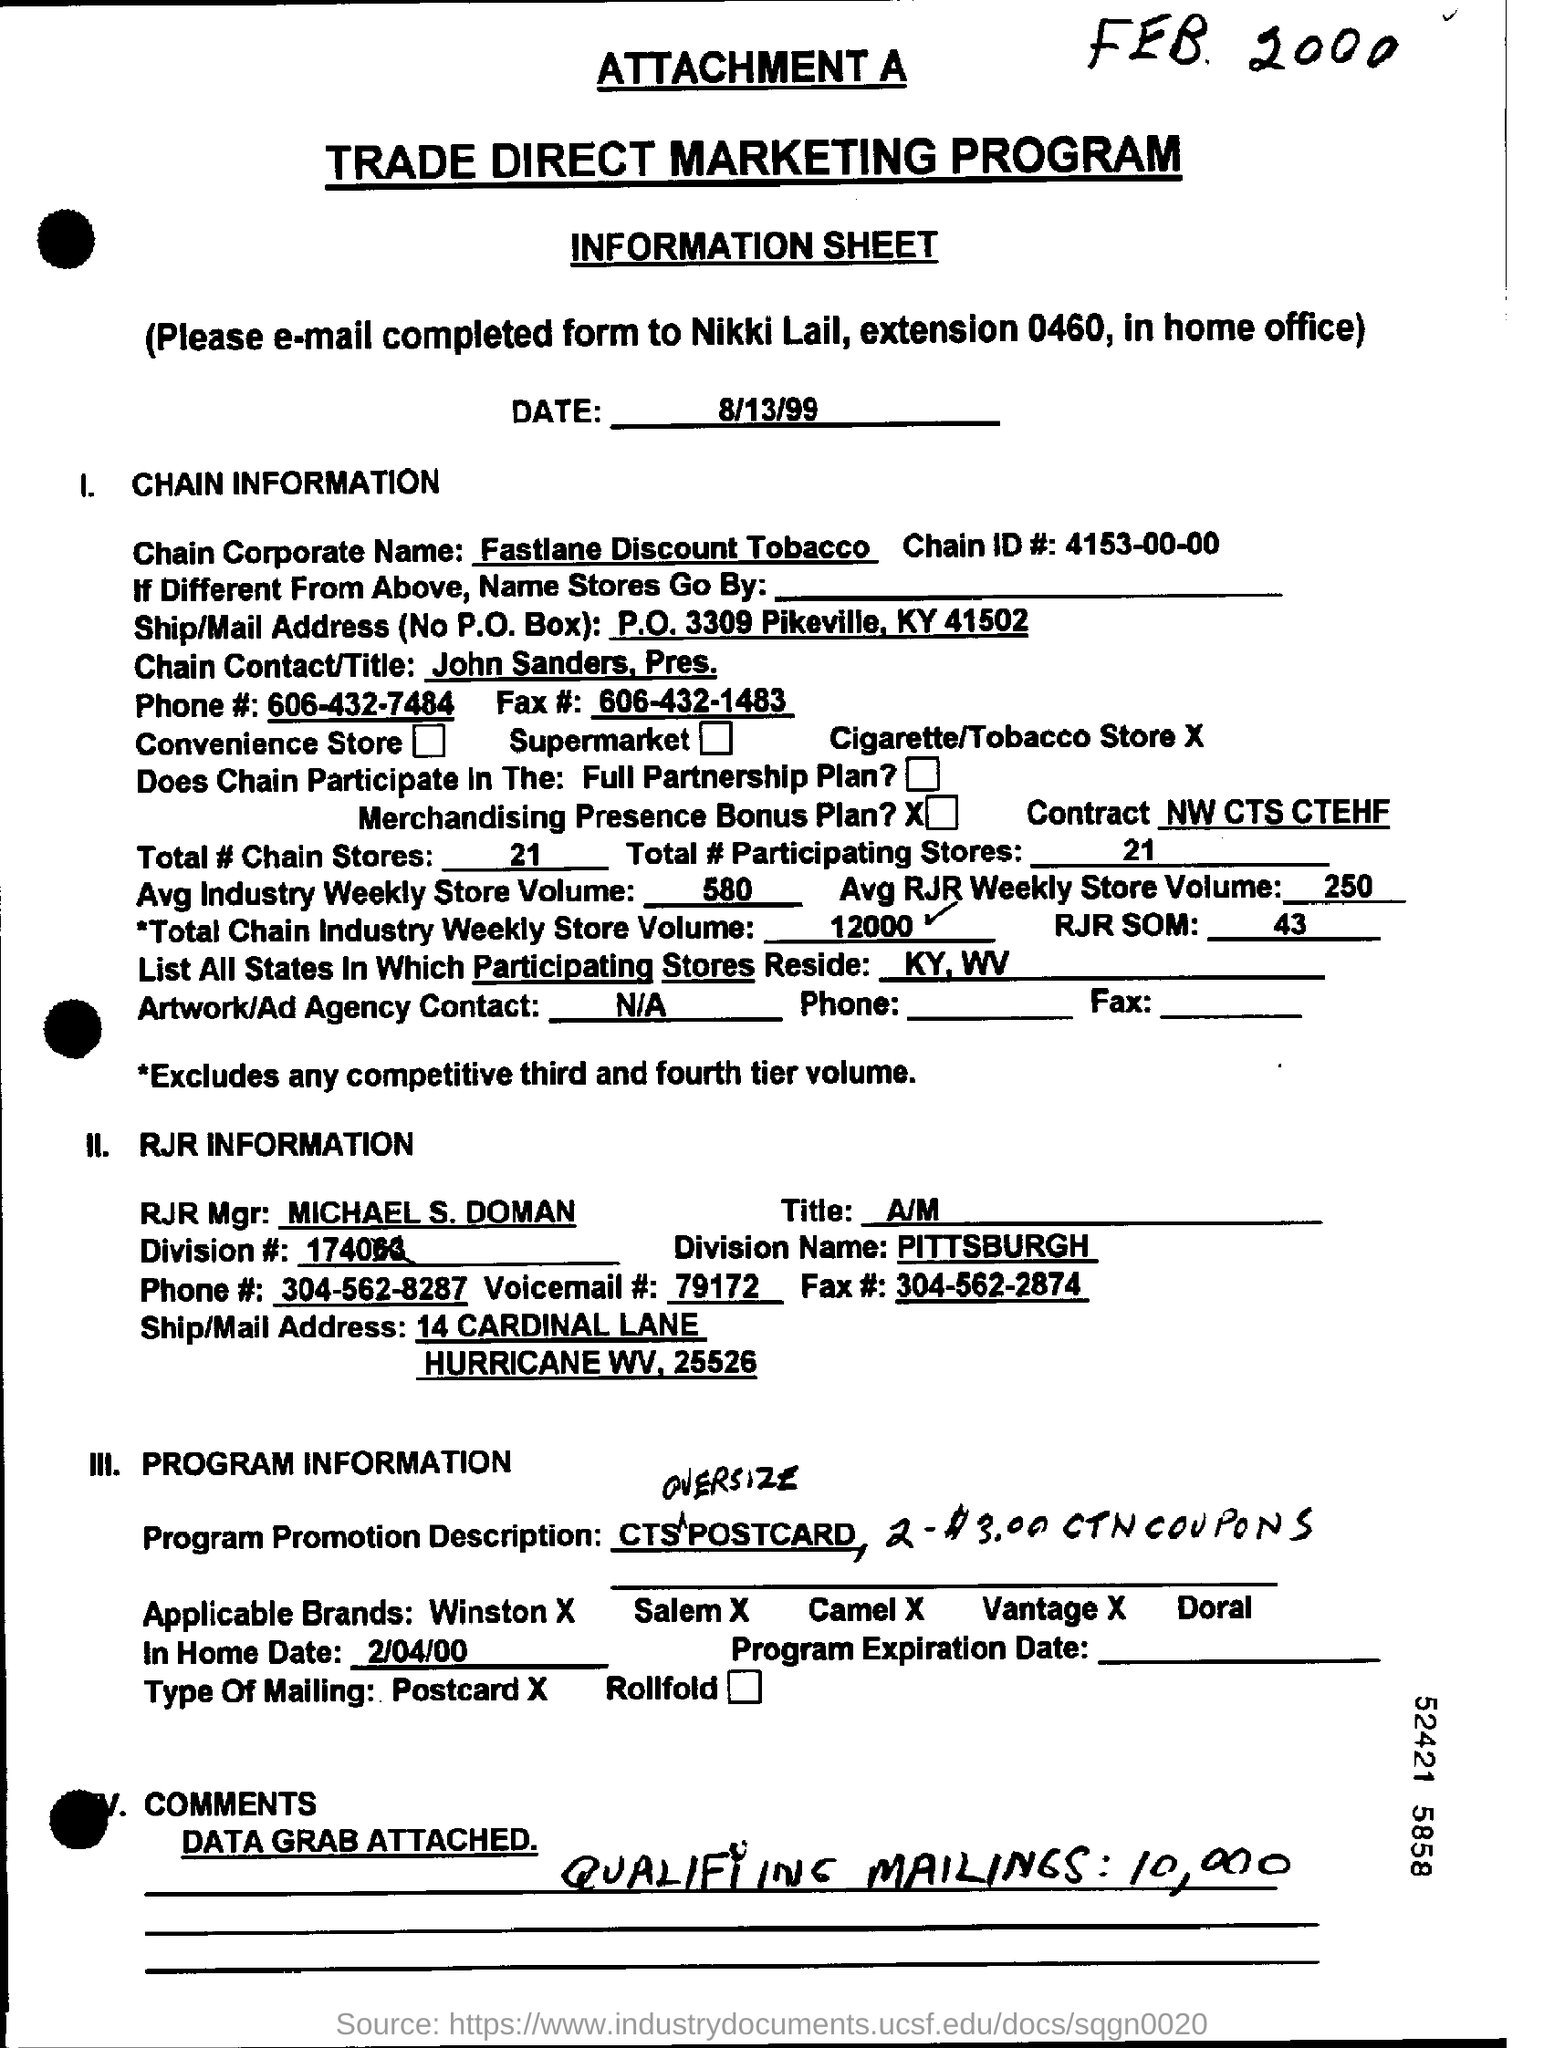Draw attention to some important aspects in this diagram. On August 13, 1999, the date is known. The chain ID is 4153-00-00. Fastlane Discount Tobacco is the corporate name of a chain. The RJR Manager's name is Michael S. Doman. The fax number is 606-432-1483. 